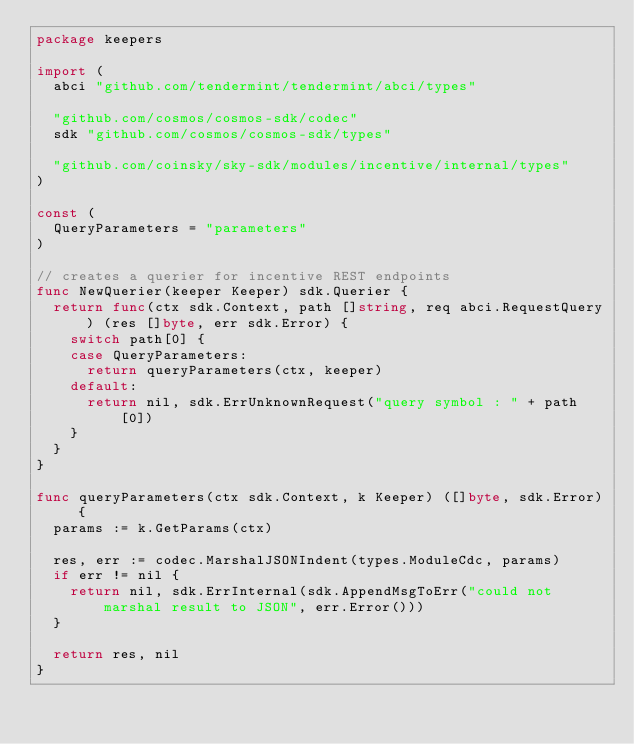Convert code to text. <code><loc_0><loc_0><loc_500><loc_500><_Go_>package keepers

import (
	abci "github.com/tendermint/tendermint/abci/types"

	"github.com/cosmos/cosmos-sdk/codec"
	sdk "github.com/cosmos/cosmos-sdk/types"

	"github.com/coinsky/sky-sdk/modules/incentive/internal/types"
)

const (
	QueryParameters = "parameters"
)

// creates a querier for incentive REST endpoints
func NewQuerier(keeper Keeper) sdk.Querier {
	return func(ctx sdk.Context, path []string, req abci.RequestQuery) (res []byte, err sdk.Error) {
		switch path[0] {
		case QueryParameters:
			return queryParameters(ctx, keeper)
		default:
			return nil, sdk.ErrUnknownRequest("query symbol : " + path[0])
		}
	}
}

func queryParameters(ctx sdk.Context, k Keeper) ([]byte, sdk.Error) {
	params := k.GetParams(ctx)

	res, err := codec.MarshalJSONIndent(types.ModuleCdc, params)
	if err != nil {
		return nil, sdk.ErrInternal(sdk.AppendMsgToErr("could not marshal result to JSON", err.Error()))
	}

	return res, nil
}
</code> 